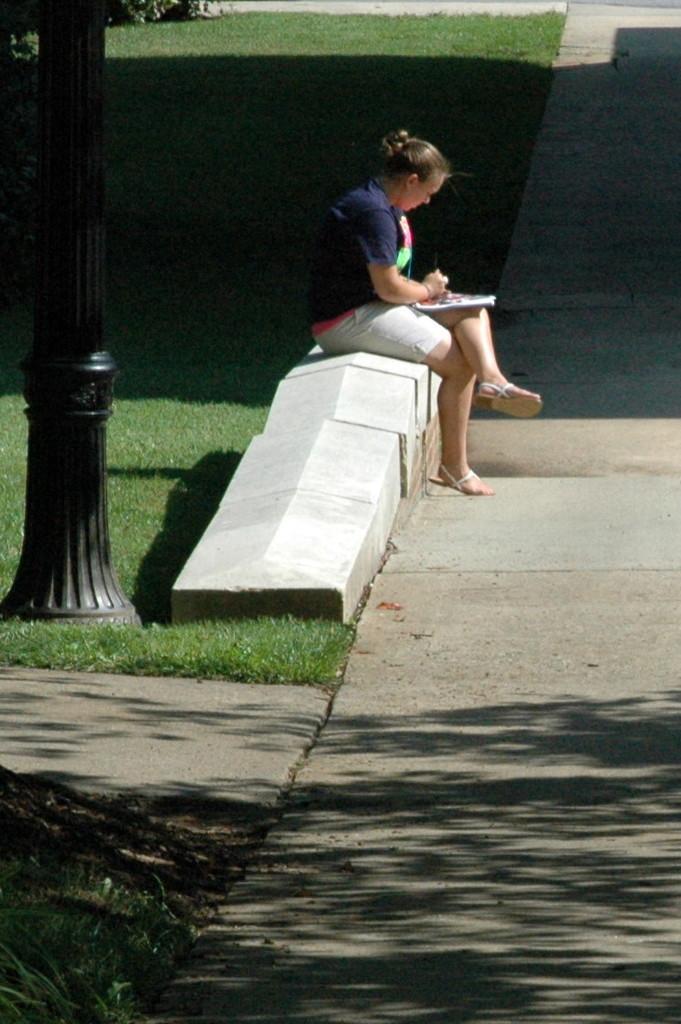Describe this image in one or two sentences. In this image we can see one black pole, three roads, some grass, trees on the ground, one woman sitting, holding a book and reading. 